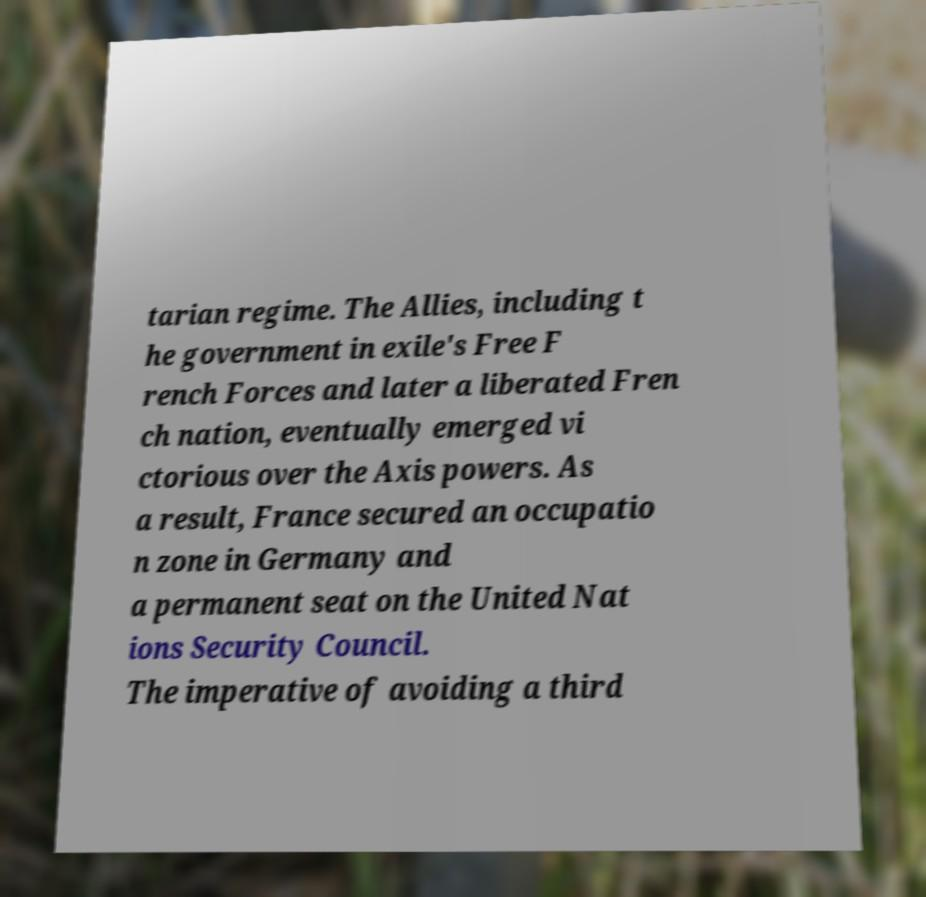Please identify and transcribe the text found in this image. tarian regime. The Allies, including t he government in exile's Free F rench Forces and later a liberated Fren ch nation, eventually emerged vi ctorious over the Axis powers. As a result, France secured an occupatio n zone in Germany and a permanent seat on the United Nat ions Security Council. The imperative of avoiding a third 